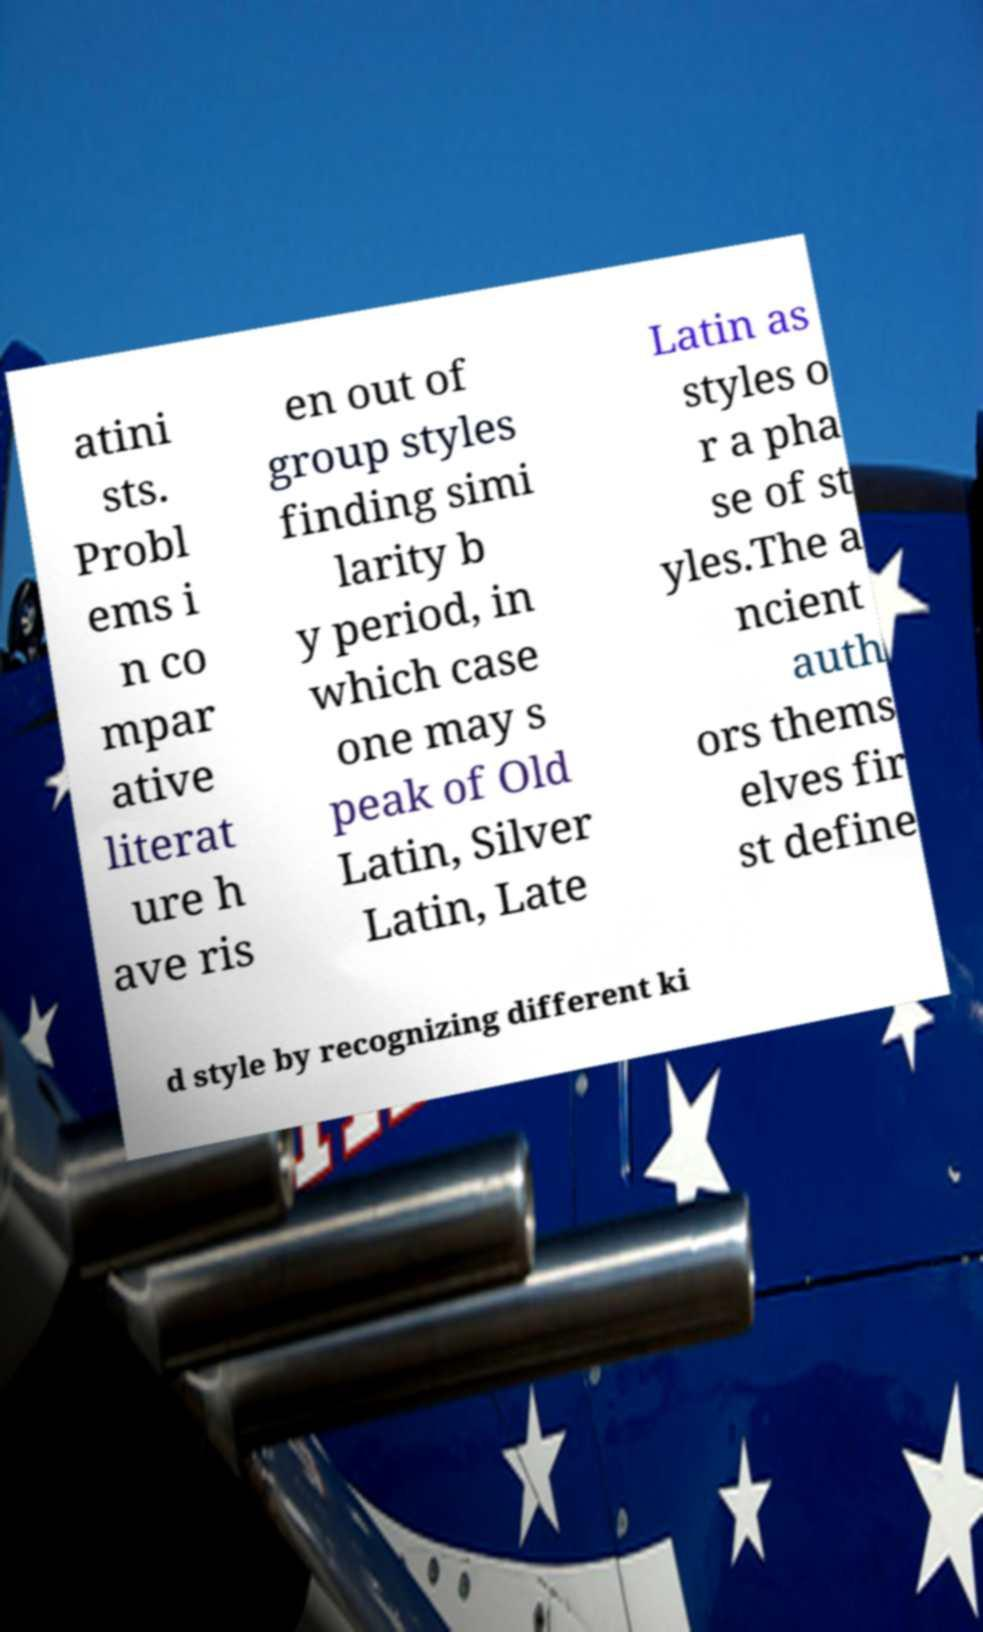Can you accurately transcribe the text from the provided image for me? atini sts. Probl ems i n co mpar ative literat ure h ave ris en out of group styles finding simi larity b y period, in which case one may s peak of Old Latin, Silver Latin, Late Latin as styles o r a pha se of st yles.The a ncient auth ors thems elves fir st define d style by recognizing different ki 